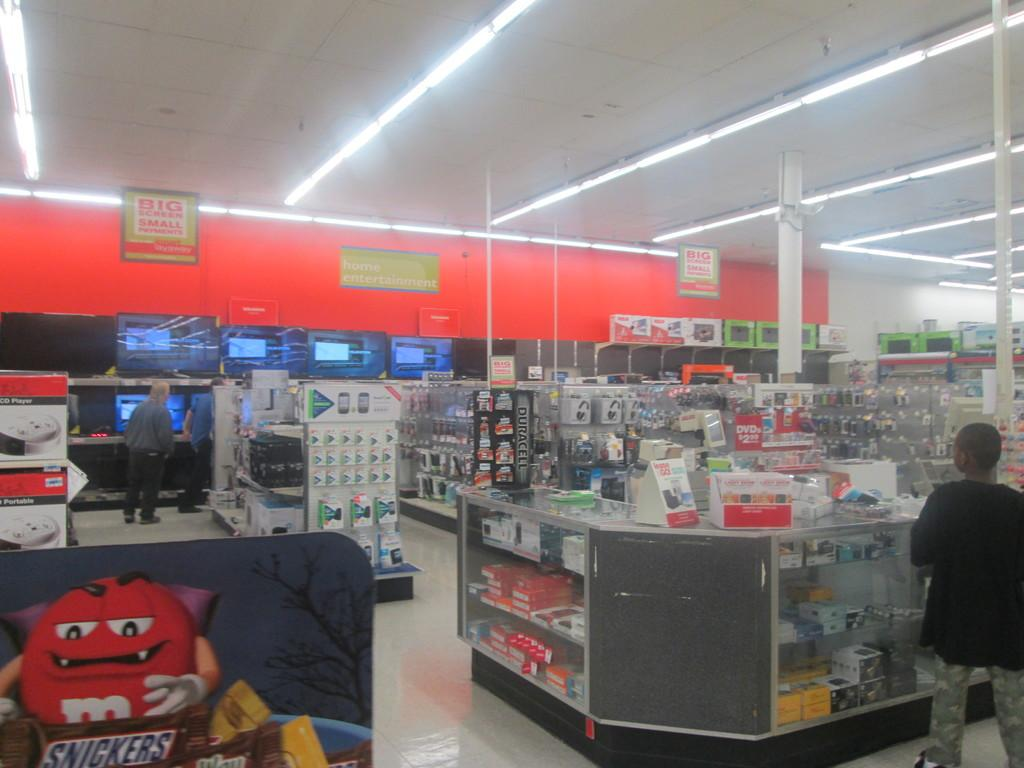<image>
Offer a succinct explanation of the picture presented. A store's electronic department has a display for Duracell batteries on the counter. 